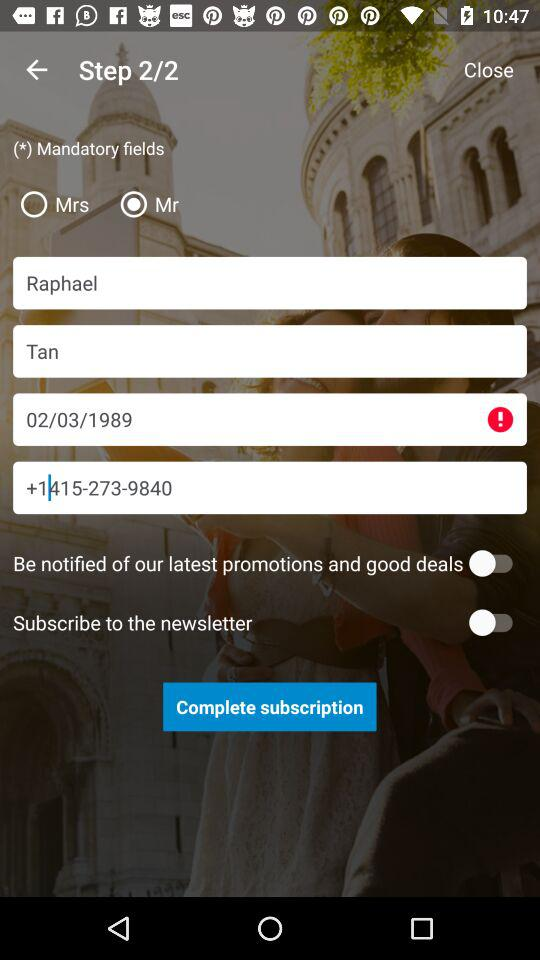What is the status of "Subscribe to the newsletter"? The status is "off". 